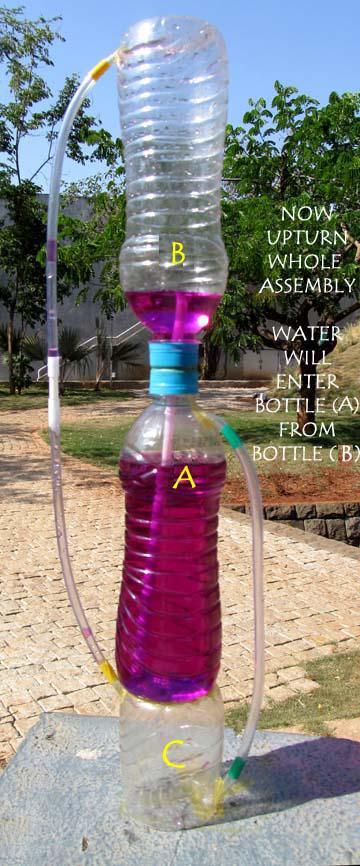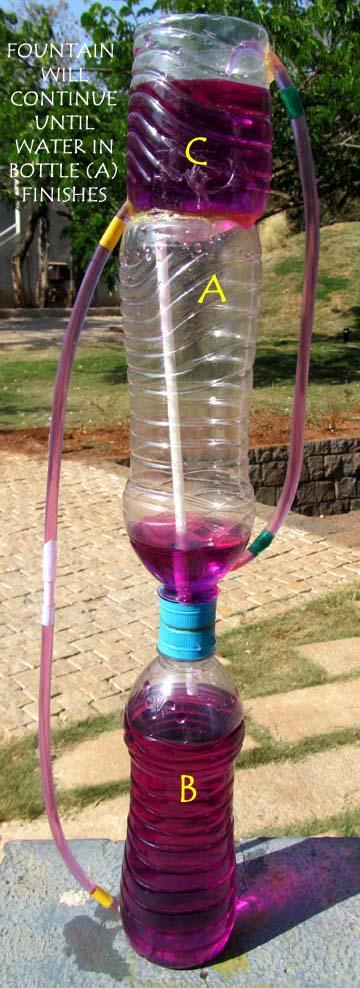The first image is the image on the left, the second image is the image on the right. Analyze the images presented: Is the assertion "Each image shows a set-up with purple liquid flowing from the top to the bottom, with blue bottle caps visible in each picture." valid? Answer yes or no. Yes. The first image is the image on the left, the second image is the image on the right. Examine the images to the left and right. Is the description "One of the images features a person demonstrating the fountain." accurate? Answer yes or no. No. 